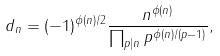<formula> <loc_0><loc_0><loc_500><loc_500>d _ { n } = ( - 1 ) ^ { \phi ( n ) / 2 } \frac { n ^ { \phi ( n ) } } { \prod _ { p | n } p ^ { \phi ( n ) / ( p - 1 ) } } ,</formula> 